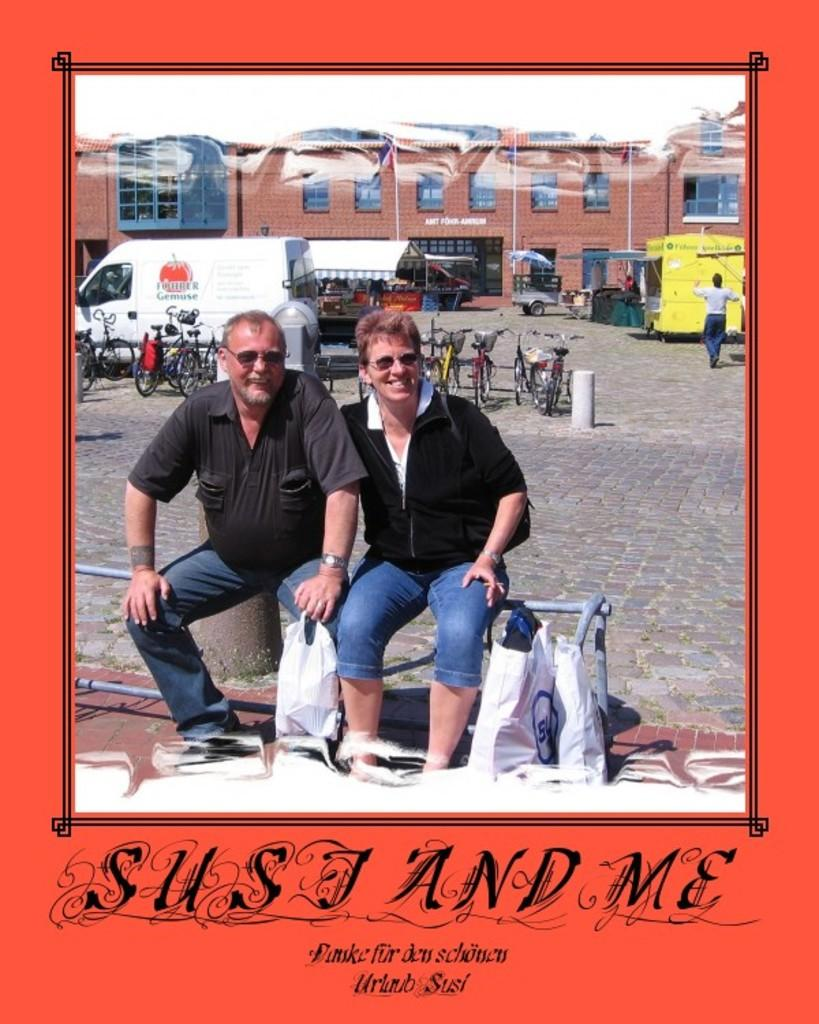Provide a one-sentence caption for the provided image. two people are sitting on a fence in a picture taht says sust and me. 